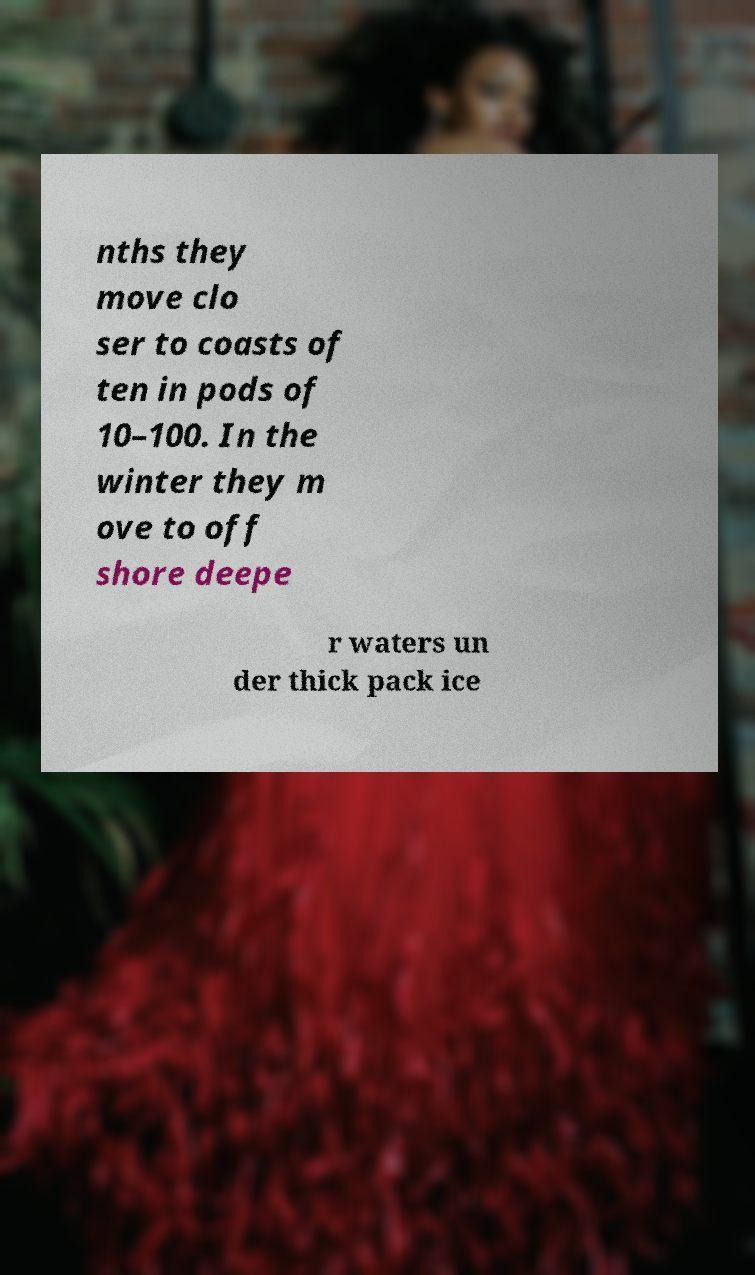There's text embedded in this image that I need extracted. Can you transcribe it verbatim? nths they move clo ser to coasts of ten in pods of 10–100. In the winter they m ove to off shore deepe r waters un der thick pack ice 